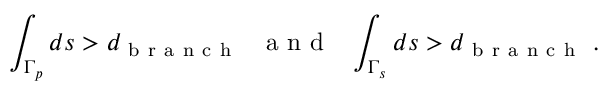Convert formula to latex. <formula><loc_0><loc_0><loc_500><loc_500>\int _ { \Gamma _ { p } } d s > d _ { b r a n c h } \ \ a n d \quad i n t _ { \Gamma _ { s } } d s > d _ { b r a n c h } \ .</formula> 